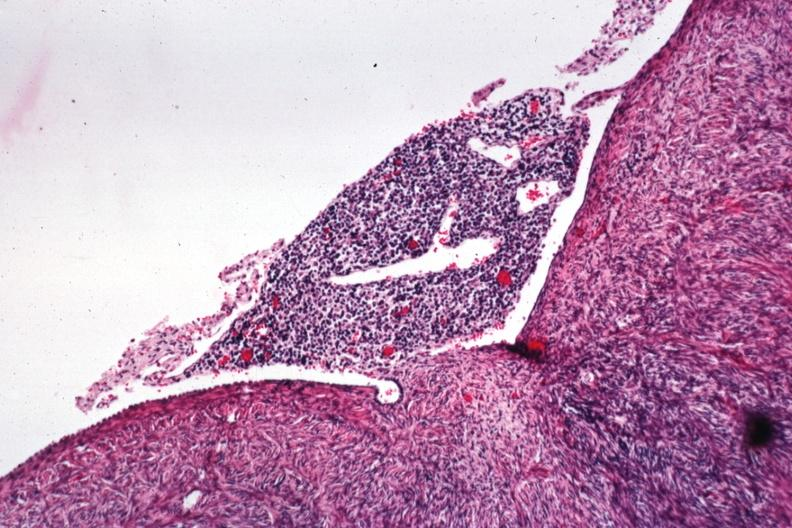s normal ovary present?
Answer the question using a single word or phrase. No 